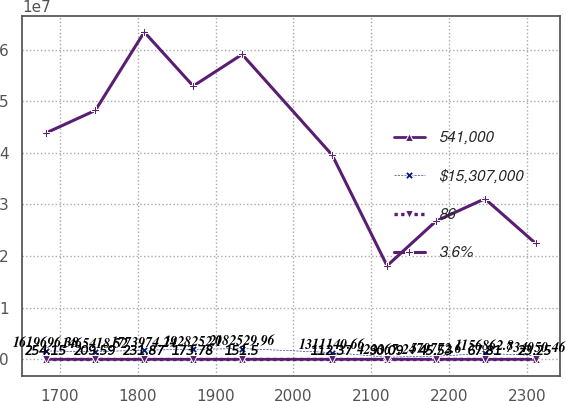<chart> <loc_0><loc_0><loc_500><loc_500><line_chart><ecel><fcel>541,000<fcel>$15,307,000<fcel>86<fcel>3.6%<nl><fcel>1682.64<fcel>254.15<fcel>1.6197e+06<fcel>11.86<fcel>4.38994e+07<nl><fcel>1745.52<fcel>209.59<fcel>1.46542e+06<fcel>10.12<fcel>4.82282e+07<nl><fcel>1808.4<fcel>231.87<fcel>1.77397e+06<fcel>10.99<fcel>6.34091e+07<nl><fcel>1871.28<fcel>173.78<fcel>1.92825e+06<fcel>9.25<fcel>5.29505e+07<nl><fcel>1934.16<fcel>151.5<fcel>2.08253e+06<fcel>12.73<fcel>5.90803e+07<nl><fcel>2049.94<fcel>112.37<fcel>1.31114e+06<fcel>8.38<fcel>3.95706e+07<nl><fcel>2120.47<fcel>90.09<fcel>423367<fcel>2.9<fcel>1.81231e+07<nl><fcel>2183.35<fcel>45.53<fcel>579773<fcel>5.17<fcel>2.67807e+07<nl><fcel>2246.23<fcel>67.81<fcel>1.15686e+06<fcel>7.51<fcel>3.11095e+07<nl><fcel>2311.47<fcel>23.25<fcel>734050<fcel>4.3<fcel>2.24519e+07<nl></chart> 